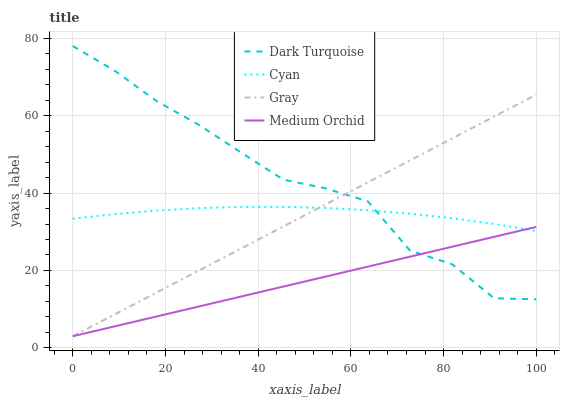Does Medium Orchid have the minimum area under the curve?
Answer yes or no. Yes. Does Dark Turquoise have the maximum area under the curve?
Answer yes or no. Yes. Does Gray have the minimum area under the curve?
Answer yes or no. No. Does Gray have the maximum area under the curve?
Answer yes or no. No. Is Gray the smoothest?
Answer yes or no. Yes. Is Dark Turquoise the roughest?
Answer yes or no. Yes. Is Medium Orchid the smoothest?
Answer yes or no. No. Is Medium Orchid the roughest?
Answer yes or no. No. Does Gray have the lowest value?
Answer yes or no. Yes. Does Cyan have the lowest value?
Answer yes or no. No. Does Dark Turquoise have the highest value?
Answer yes or no. Yes. Does Gray have the highest value?
Answer yes or no. No. Does Dark Turquoise intersect Medium Orchid?
Answer yes or no. Yes. Is Dark Turquoise less than Medium Orchid?
Answer yes or no. No. Is Dark Turquoise greater than Medium Orchid?
Answer yes or no. No. 